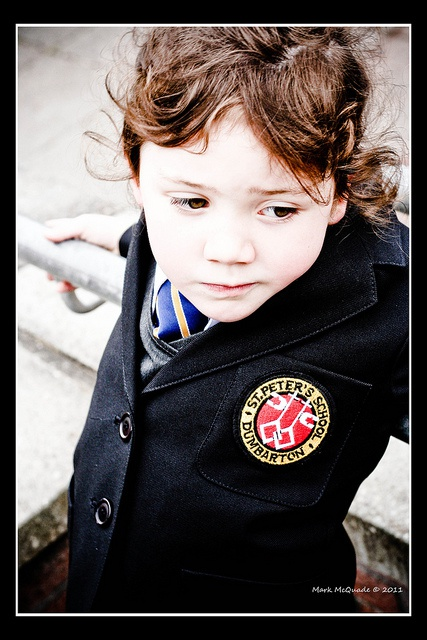Describe the objects in this image and their specific colors. I can see people in black, white, gray, and maroon tones and tie in black, lightblue, white, and darkblue tones in this image. 